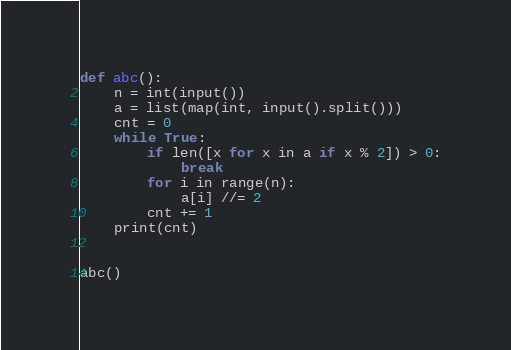Convert code to text. <code><loc_0><loc_0><loc_500><loc_500><_Python_>def abc():
    n = int(input())
    a = list(map(int, input().split()))
    cnt = 0
    while True:
        if len([x for x in a if x % 2]) > 0:
            break
        for i in range(n):
            a[i] //= 2
        cnt += 1
    print(cnt)


abc()
</code> 